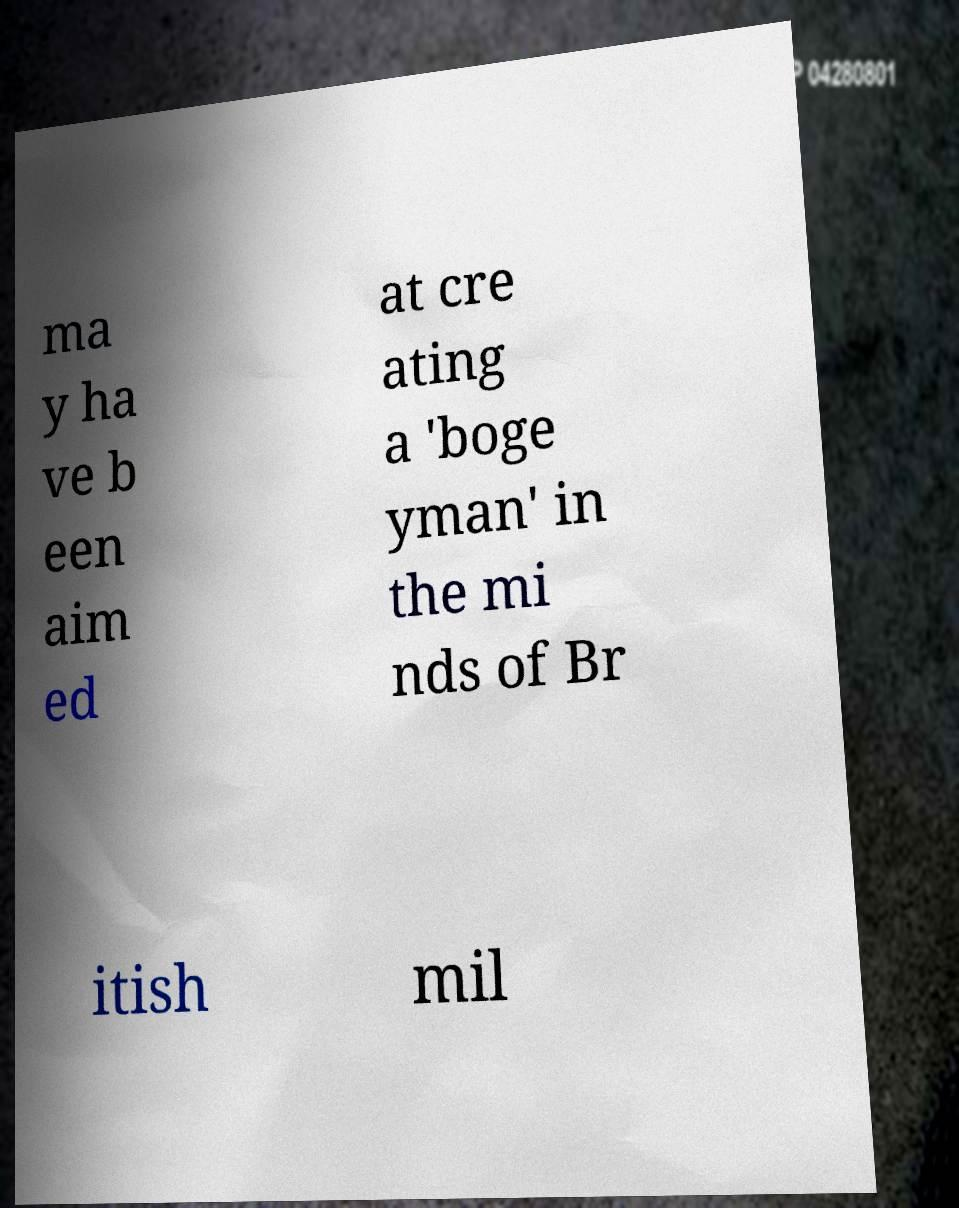I need the written content from this picture converted into text. Can you do that? ma y ha ve b een aim ed at cre ating a 'boge yman' in the mi nds of Br itish mil 